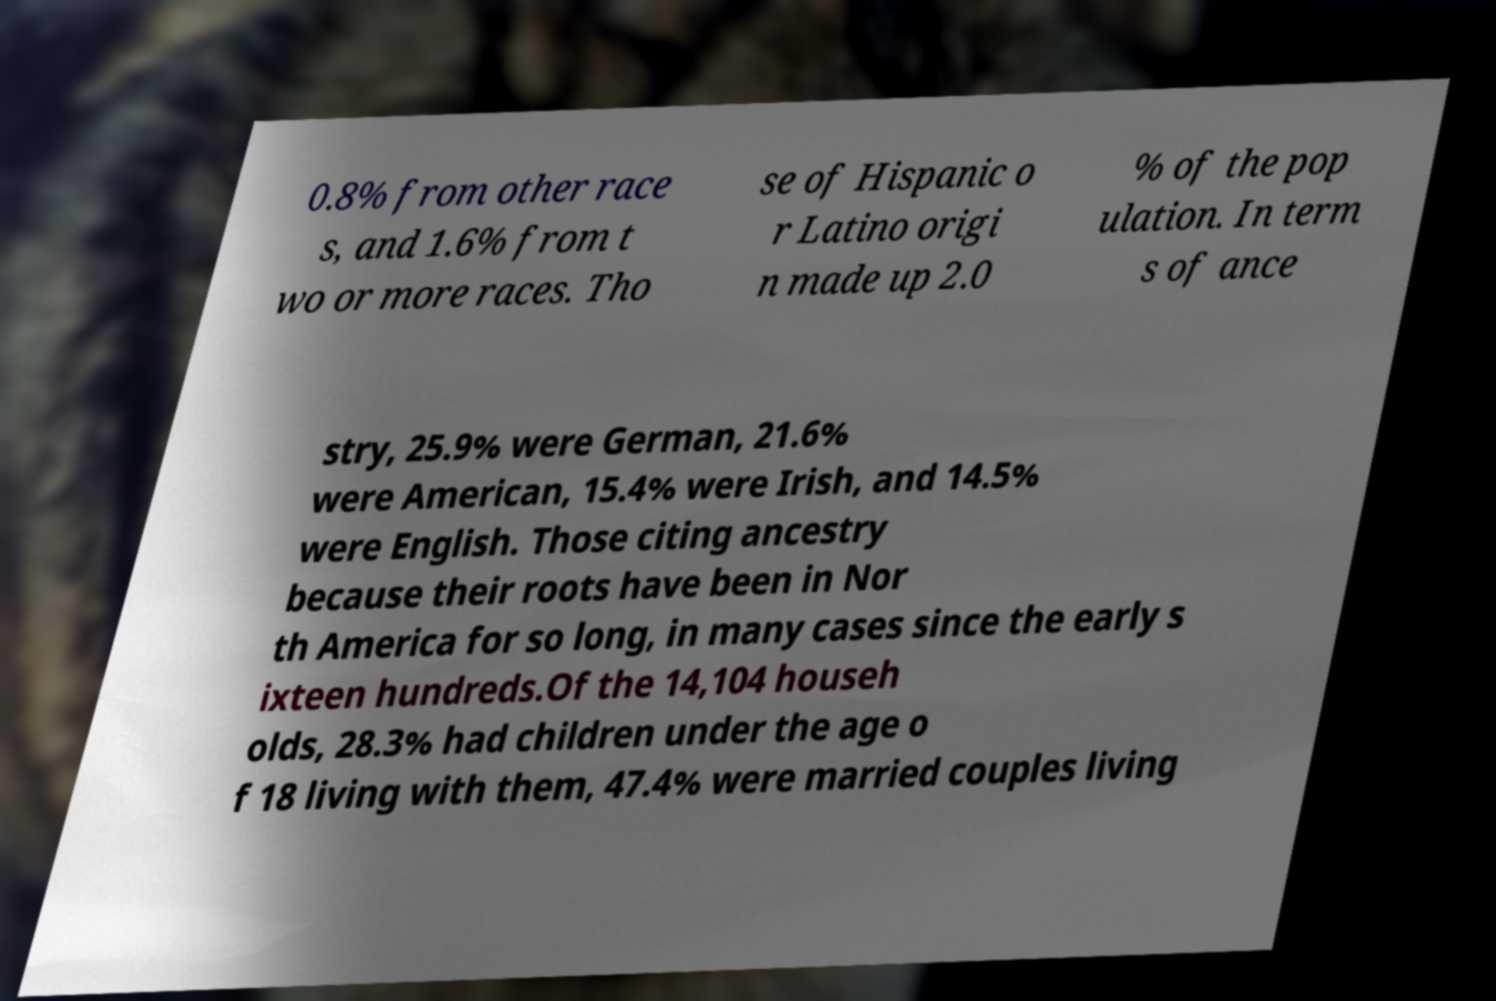Please identify and transcribe the text found in this image. 0.8% from other race s, and 1.6% from t wo or more races. Tho se of Hispanic o r Latino origi n made up 2.0 % of the pop ulation. In term s of ance stry, 25.9% were German, 21.6% were American, 15.4% were Irish, and 14.5% were English. Those citing ancestry because their roots have been in Nor th America for so long, in many cases since the early s ixteen hundreds.Of the 14,104 househ olds, 28.3% had children under the age o f 18 living with them, 47.4% were married couples living 